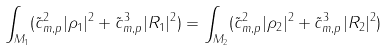Convert formula to latex. <formula><loc_0><loc_0><loc_500><loc_500>\int _ { M _ { 1 } } ( \tilde { c } _ { m , p } ^ { 2 } | \rho _ { 1 } | ^ { 2 } + \tilde { c } _ { m , p } ^ { 3 } | R _ { 1 } | ^ { 2 } ) = \int _ { M _ { 2 } } ( \tilde { c } _ { m , p } ^ { 2 } | \rho _ { 2 } | ^ { 2 } + \tilde { c } _ { m , p } ^ { 3 } | R _ { 2 } | ^ { 2 } )</formula> 